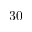Convert formula to latex. <formula><loc_0><loc_0><loc_500><loc_500>3 0</formula> 